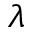<formula> <loc_0><loc_0><loc_500><loc_500>\lambda</formula> 